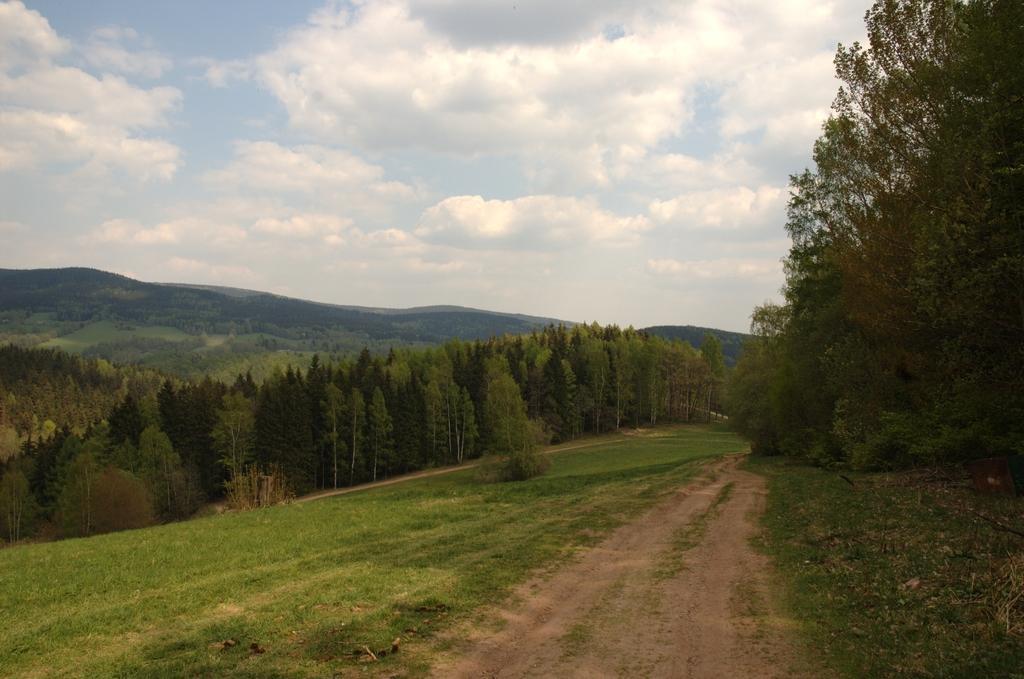Describe this image in one or two sentences. At the bottom of the picture, we see the grass and the pathway. On the right side, we see the grass and the trees. There are trees in the middle of the picture. We see the trees and the hills in the background. At the top, we see the sky and the clouds. 